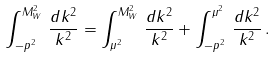<formula> <loc_0><loc_0><loc_500><loc_500>\int _ { - p ^ { 2 } } ^ { M _ { W } ^ { 2 } } \, \frac { d k ^ { 2 } } { k ^ { 2 } } = \int _ { \mu ^ { 2 } } ^ { M _ { W } ^ { 2 } } \, \frac { d k ^ { 2 } } { k ^ { 2 } } + \int _ { - p ^ { 2 } } ^ { \mu ^ { 2 } } \, \frac { d k ^ { 2 } } { k ^ { 2 } } \, .</formula> 